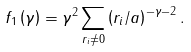<formula> <loc_0><loc_0><loc_500><loc_500>f _ { 1 } \left ( \gamma \right ) = \gamma ^ { 2 } \sum _ { { r } _ { i } \neq 0 } \left ( r _ { i } / a \right ) ^ { - \gamma - 2 } .</formula> 